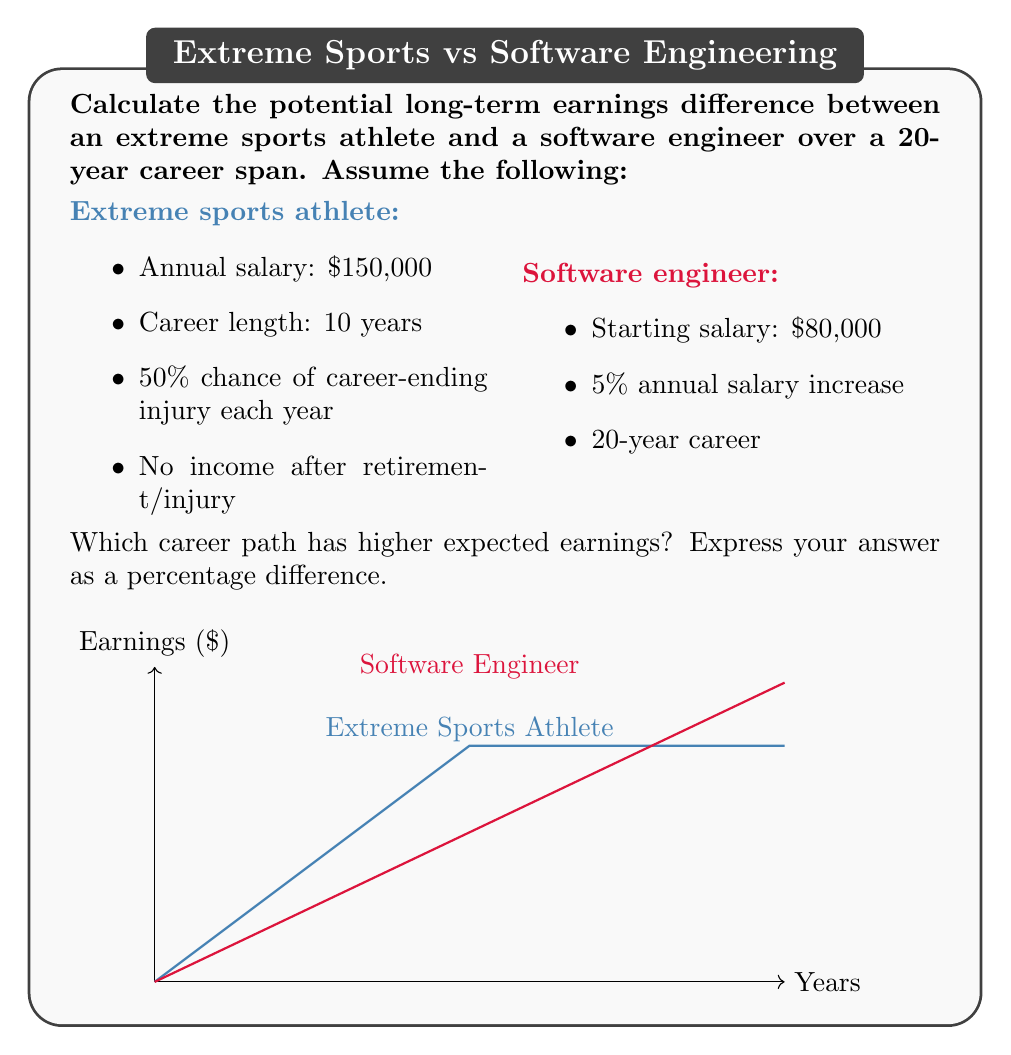Can you solve this math problem? Let's approach this step-by-step:

1) First, calculate the expected earnings for the extreme sports athlete:

   The probability of still being active after $n$ years is $(0.5)^n$.
   Expected earnings = $\sum_{n=1}^{10} 150000 \cdot (0.5)^n$

   This is a geometric series with first term $a = 75000$ and ratio $r = 0.5$
   Sum = $\frac{a(1-r^n)}{1-r} = \frac{75000(1-0.5^{10})}{0.5} = 149812.5$

   Expected total earnings: $149,812.50

2) Now, calculate the earnings for the software engineer:

   Salary in year $n$ = $80000 \cdot (1.05)^{n-1}$
   Total earnings = $\sum_{n=1}^{20} 80000 \cdot (1.05)^{n-1}$

   This is a geometric series with $a = 80000$ and $r = 1.05$
   Sum = $\frac{a(1-r^n)}{1-r} = \frac{80000(1-1.05^{20})}{-0.05} = 2,786,923.98$

3) Calculate the percentage difference:

   Difference = $\frac{2786923.98 - 149812.50}{149812.50} \cdot 100\% = 1759.63\%$

The software engineer career path has 1759.63% higher expected earnings.
Answer: 1759.63% higher for software engineer 